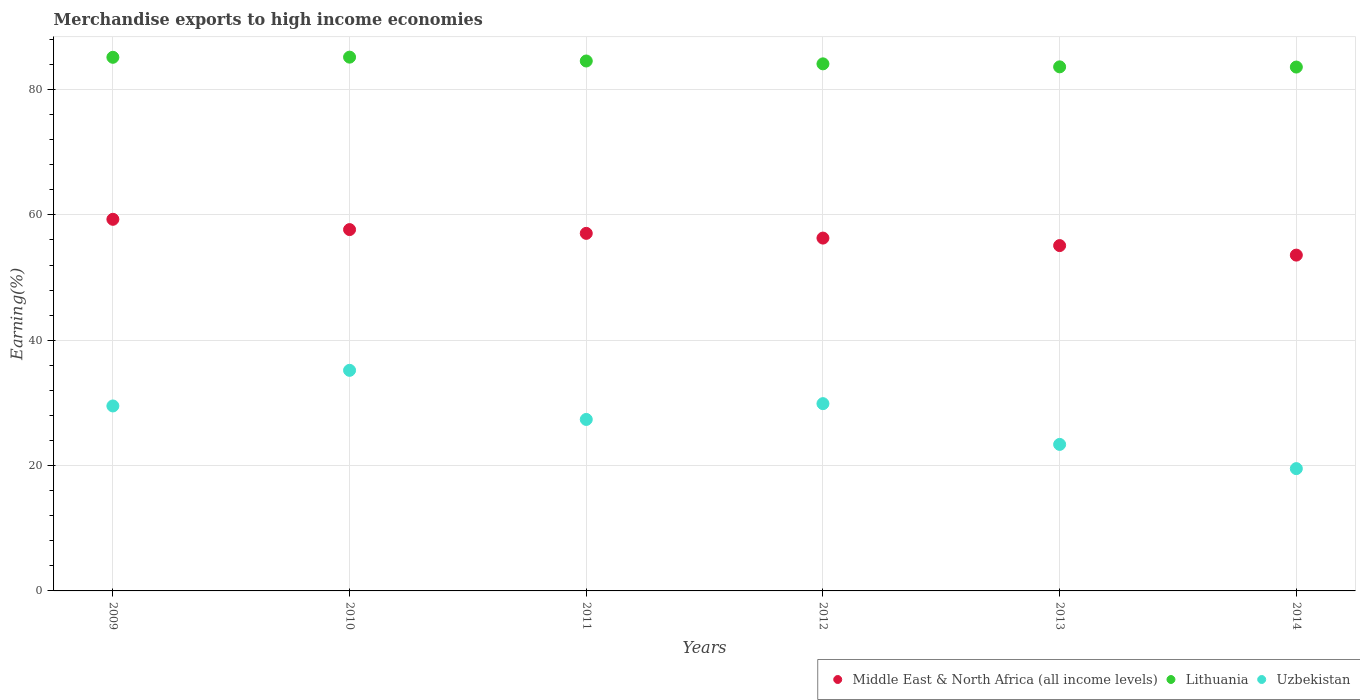What is the percentage of amount earned from merchandise exports in Middle East & North Africa (all income levels) in 2013?
Provide a short and direct response. 55.1. Across all years, what is the maximum percentage of amount earned from merchandise exports in Uzbekistan?
Your answer should be very brief. 35.2. Across all years, what is the minimum percentage of amount earned from merchandise exports in Lithuania?
Offer a terse response. 83.59. In which year was the percentage of amount earned from merchandise exports in Uzbekistan minimum?
Keep it short and to the point. 2014. What is the total percentage of amount earned from merchandise exports in Uzbekistan in the graph?
Ensure brevity in your answer.  164.84. What is the difference between the percentage of amount earned from merchandise exports in Uzbekistan in 2009 and that in 2010?
Offer a very short reply. -5.68. What is the difference between the percentage of amount earned from merchandise exports in Middle East & North Africa (all income levels) in 2014 and the percentage of amount earned from merchandise exports in Lithuania in 2009?
Ensure brevity in your answer.  -31.56. What is the average percentage of amount earned from merchandise exports in Lithuania per year?
Provide a succinct answer. 84.36. In the year 2014, what is the difference between the percentage of amount earned from merchandise exports in Lithuania and percentage of amount earned from merchandise exports in Uzbekistan?
Provide a succinct answer. 64.07. What is the ratio of the percentage of amount earned from merchandise exports in Lithuania in 2011 to that in 2013?
Your response must be concise. 1.01. Is the percentage of amount earned from merchandise exports in Middle East & North Africa (all income levels) in 2012 less than that in 2013?
Provide a succinct answer. No. What is the difference between the highest and the second highest percentage of amount earned from merchandise exports in Middle East & North Africa (all income levels)?
Ensure brevity in your answer.  1.64. What is the difference between the highest and the lowest percentage of amount earned from merchandise exports in Uzbekistan?
Your answer should be very brief. 15.68. In how many years, is the percentage of amount earned from merchandise exports in Uzbekistan greater than the average percentage of amount earned from merchandise exports in Uzbekistan taken over all years?
Provide a short and direct response. 3. Is it the case that in every year, the sum of the percentage of amount earned from merchandise exports in Middle East & North Africa (all income levels) and percentage of amount earned from merchandise exports in Lithuania  is greater than the percentage of amount earned from merchandise exports in Uzbekistan?
Keep it short and to the point. Yes. Does the percentage of amount earned from merchandise exports in Lithuania monotonically increase over the years?
Your answer should be compact. No. How many dotlines are there?
Provide a short and direct response. 3. What is the difference between two consecutive major ticks on the Y-axis?
Your answer should be compact. 20. Are the values on the major ticks of Y-axis written in scientific E-notation?
Keep it short and to the point. No. Does the graph contain any zero values?
Keep it short and to the point. No. Does the graph contain grids?
Make the answer very short. Yes. Where does the legend appear in the graph?
Offer a very short reply. Bottom right. How many legend labels are there?
Provide a succinct answer. 3. How are the legend labels stacked?
Provide a short and direct response. Horizontal. What is the title of the graph?
Keep it short and to the point. Merchandise exports to high income economies. What is the label or title of the X-axis?
Your response must be concise. Years. What is the label or title of the Y-axis?
Give a very brief answer. Earning(%). What is the Earning(%) of Middle East & North Africa (all income levels) in 2009?
Your answer should be compact. 59.29. What is the Earning(%) in Lithuania in 2009?
Provide a succinct answer. 85.14. What is the Earning(%) in Uzbekistan in 2009?
Provide a short and direct response. 29.51. What is the Earning(%) of Middle East & North Africa (all income levels) in 2010?
Your response must be concise. 57.65. What is the Earning(%) in Lithuania in 2010?
Keep it short and to the point. 85.17. What is the Earning(%) of Uzbekistan in 2010?
Give a very brief answer. 35.2. What is the Earning(%) in Middle East & North Africa (all income levels) in 2011?
Your response must be concise. 57.05. What is the Earning(%) of Lithuania in 2011?
Your answer should be very brief. 84.55. What is the Earning(%) in Uzbekistan in 2011?
Your response must be concise. 27.36. What is the Earning(%) of Middle East & North Africa (all income levels) in 2012?
Keep it short and to the point. 56.3. What is the Earning(%) of Lithuania in 2012?
Ensure brevity in your answer.  84.1. What is the Earning(%) in Uzbekistan in 2012?
Offer a very short reply. 29.88. What is the Earning(%) in Middle East & North Africa (all income levels) in 2013?
Ensure brevity in your answer.  55.1. What is the Earning(%) in Lithuania in 2013?
Your response must be concise. 83.62. What is the Earning(%) in Uzbekistan in 2013?
Ensure brevity in your answer.  23.38. What is the Earning(%) of Middle East & North Africa (all income levels) in 2014?
Give a very brief answer. 53.58. What is the Earning(%) in Lithuania in 2014?
Keep it short and to the point. 83.59. What is the Earning(%) of Uzbekistan in 2014?
Give a very brief answer. 19.51. Across all years, what is the maximum Earning(%) of Middle East & North Africa (all income levels)?
Offer a terse response. 59.29. Across all years, what is the maximum Earning(%) of Lithuania?
Ensure brevity in your answer.  85.17. Across all years, what is the maximum Earning(%) in Uzbekistan?
Make the answer very short. 35.2. Across all years, what is the minimum Earning(%) of Middle East & North Africa (all income levels)?
Offer a terse response. 53.58. Across all years, what is the minimum Earning(%) in Lithuania?
Your answer should be very brief. 83.59. Across all years, what is the minimum Earning(%) in Uzbekistan?
Your answer should be very brief. 19.51. What is the total Earning(%) in Middle East & North Africa (all income levels) in the graph?
Your response must be concise. 338.98. What is the total Earning(%) of Lithuania in the graph?
Your answer should be compact. 506.17. What is the total Earning(%) of Uzbekistan in the graph?
Your answer should be very brief. 164.84. What is the difference between the Earning(%) in Middle East & North Africa (all income levels) in 2009 and that in 2010?
Give a very brief answer. 1.64. What is the difference between the Earning(%) of Lithuania in 2009 and that in 2010?
Offer a terse response. -0.02. What is the difference between the Earning(%) of Uzbekistan in 2009 and that in 2010?
Your answer should be compact. -5.68. What is the difference between the Earning(%) of Middle East & North Africa (all income levels) in 2009 and that in 2011?
Your answer should be compact. 2.24. What is the difference between the Earning(%) in Lithuania in 2009 and that in 2011?
Your answer should be very brief. 0.59. What is the difference between the Earning(%) in Uzbekistan in 2009 and that in 2011?
Your answer should be very brief. 2.15. What is the difference between the Earning(%) of Middle East & North Africa (all income levels) in 2009 and that in 2012?
Ensure brevity in your answer.  3. What is the difference between the Earning(%) of Lithuania in 2009 and that in 2012?
Offer a terse response. 1.05. What is the difference between the Earning(%) of Uzbekistan in 2009 and that in 2012?
Your response must be concise. -0.37. What is the difference between the Earning(%) in Middle East & North Africa (all income levels) in 2009 and that in 2013?
Make the answer very short. 4.19. What is the difference between the Earning(%) in Lithuania in 2009 and that in 2013?
Provide a succinct answer. 1.52. What is the difference between the Earning(%) of Uzbekistan in 2009 and that in 2013?
Provide a succinct answer. 6.13. What is the difference between the Earning(%) in Middle East & North Africa (all income levels) in 2009 and that in 2014?
Make the answer very short. 5.71. What is the difference between the Earning(%) of Lithuania in 2009 and that in 2014?
Provide a succinct answer. 1.56. What is the difference between the Earning(%) in Uzbekistan in 2009 and that in 2014?
Make the answer very short. 10. What is the difference between the Earning(%) of Middle East & North Africa (all income levels) in 2010 and that in 2011?
Ensure brevity in your answer.  0.6. What is the difference between the Earning(%) in Lithuania in 2010 and that in 2011?
Your response must be concise. 0.61. What is the difference between the Earning(%) of Uzbekistan in 2010 and that in 2011?
Make the answer very short. 7.83. What is the difference between the Earning(%) in Middle East & North Africa (all income levels) in 2010 and that in 2012?
Your answer should be very brief. 1.35. What is the difference between the Earning(%) of Lithuania in 2010 and that in 2012?
Give a very brief answer. 1.07. What is the difference between the Earning(%) of Uzbekistan in 2010 and that in 2012?
Keep it short and to the point. 5.32. What is the difference between the Earning(%) in Middle East & North Africa (all income levels) in 2010 and that in 2013?
Provide a short and direct response. 2.55. What is the difference between the Earning(%) of Lithuania in 2010 and that in 2013?
Your answer should be compact. 1.55. What is the difference between the Earning(%) of Uzbekistan in 2010 and that in 2013?
Your response must be concise. 11.82. What is the difference between the Earning(%) in Middle East & North Africa (all income levels) in 2010 and that in 2014?
Your answer should be very brief. 4.07. What is the difference between the Earning(%) of Lithuania in 2010 and that in 2014?
Your answer should be very brief. 1.58. What is the difference between the Earning(%) in Uzbekistan in 2010 and that in 2014?
Your answer should be very brief. 15.68. What is the difference between the Earning(%) in Middle East & North Africa (all income levels) in 2011 and that in 2012?
Keep it short and to the point. 0.75. What is the difference between the Earning(%) in Lithuania in 2011 and that in 2012?
Your answer should be very brief. 0.46. What is the difference between the Earning(%) of Uzbekistan in 2011 and that in 2012?
Provide a succinct answer. -2.52. What is the difference between the Earning(%) in Middle East & North Africa (all income levels) in 2011 and that in 2013?
Your answer should be compact. 1.95. What is the difference between the Earning(%) of Lithuania in 2011 and that in 2013?
Your answer should be compact. 0.93. What is the difference between the Earning(%) of Uzbekistan in 2011 and that in 2013?
Your response must be concise. 3.98. What is the difference between the Earning(%) of Middle East & North Africa (all income levels) in 2011 and that in 2014?
Provide a short and direct response. 3.47. What is the difference between the Earning(%) in Lithuania in 2011 and that in 2014?
Offer a terse response. 0.97. What is the difference between the Earning(%) of Uzbekistan in 2011 and that in 2014?
Your answer should be compact. 7.85. What is the difference between the Earning(%) of Middle East & North Africa (all income levels) in 2012 and that in 2013?
Offer a very short reply. 1.2. What is the difference between the Earning(%) of Lithuania in 2012 and that in 2013?
Provide a short and direct response. 0.48. What is the difference between the Earning(%) in Uzbekistan in 2012 and that in 2013?
Your answer should be compact. 6.5. What is the difference between the Earning(%) of Middle East & North Africa (all income levels) in 2012 and that in 2014?
Your answer should be very brief. 2.72. What is the difference between the Earning(%) in Lithuania in 2012 and that in 2014?
Your answer should be compact. 0.51. What is the difference between the Earning(%) in Uzbekistan in 2012 and that in 2014?
Your response must be concise. 10.37. What is the difference between the Earning(%) of Middle East & North Africa (all income levels) in 2013 and that in 2014?
Offer a very short reply. 1.52. What is the difference between the Earning(%) in Lithuania in 2013 and that in 2014?
Ensure brevity in your answer.  0.03. What is the difference between the Earning(%) of Uzbekistan in 2013 and that in 2014?
Your answer should be very brief. 3.86. What is the difference between the Earning(%) in Middle East & North Africa (all income levels) in 2009 and the Earning(%) in Lithuania in 2010?
Provide a short and direct response. -25.87. What is the difference between the Earning(%) in Middle East & North Africa (all income levels) in 2009 and the Earning(%) in Uzbekistan in 2010?
Offer a terse response. 24.1. What is the difference between the Earning(%) in Lithuania in 2009 and the Earning(%) in Uzbekistan in 2010?
Offer a terse response. 49.95. What is the difference between the Earning(%) of Middle East & North Africa (all income levels) in 2009 and the Earning(%) of Lithuania in 2011?
Provide a succinct answer. -25.26. What is the difference between the Earning(%) of Middle East & North Africa (all income levels) in 2009 and the Earning(%) of Uzbekistan in 2011?
Your answer should be compact. 31.93. What is the difference between the Earning(%) in Lithuania in 2009 and the Earning(%) in Uzbekistan in 2011?
Your response must be concise. 57.78. What is the difference between the Earning(%) of Middle East & North Africa (all income levels) in 2009 and the Earning(%) of Lithuania in 2012?
Offer a very short reply. -24.8. What is the difference between the Earning(%) of Middle East & North Africa (all income levels) in 2009 and the Earning(%) of Uzbekistan in 2012?
Offer a very short reply. 29.41. What is the difference between the Earning(%) in Lithuania in 2009 and the Earning(%) in Uzbekistan in 2012?
Provide a succinct answer. 55.26. What is the difference between the Earning(%) of Middle East & North Africa (all income levels) in 2009 and the Earning(%) of Lithuania in 2013?
Provide a short and direct response. -24.33. What is the difference between the Earning(%) in Middle East & North Africa (all income levels) in 2009 and the Earning(%) in Uzbekistan in 2013?
Your answer should be very brief. 35.92. What is the difference between the Earning(%) in Lithuania in 2009 and the Earning(%) in Uzbekistan in 2013?
Keep it short and to the point. 61.77. What is the difference between the Earning(%) of Middle East & North Africa (all income levels) in 2009 and the Earning(%) of Lithuania in 2014?
Offer a terse response. -24.29. What is the difference between the Earning(%) in Middle East & North Africa (all income levels) in 2009 and the Earning(%) in Uzbekistan in 2014?
Provide a short and direct response. 39.78. What is the difference between the Earning(%) of Lithuania in 2009 and the Earning(%) of Uzbekistan in 2014?
Make the answer very short. 65.63. What is the difference between the Earning(%) in Middle East & North Africa (all income levels) in 2010 and the Earning(%) in Lithuania in 2011?
Make the answer very short. -26.9. What is the difference between the Earning(%) in Middle East & North Africa (all income levels) in 2010 and the Earning(%) in Uzbekistan in 2011?
Provide a succinct answer. 30.29. What is the difference between the Earning(%) of Lithuania in 2010 and the Earning(%) of Uzbekistan in 2011?
Your answer should be compact. 57.8. What is the difference between the Earning(%) in Middle East & North Africa (all income levels) in 2010 and the Earning(%) in Lithuania in 2012?
Offer a very short reply. -26.45. What is the difference between the Earning(%) of Middle East & North Africa (all income levels) in 2010 and the Earning(%) of Uzbekistan in 2012?
Provide a short and direct response. 27.77. What is the difference between the Earning(%) in Lithuania in 2010 and the Earning(%) in Uzbekistan in 2012?
Provide a short and direct response. 55.29. What is the difference between the Earning(%) in Middle East & North Africa (all income levels) in 2010 and the Earning(%) in Lithuania in 2013?
Ensure brevity in your answer.  -25.97. What is the difference between the Earning(%) in Middle East & North Africa (all income levels) in 2010 and the Earning(%) in Uzbekistan in 2013?
Provide a short and direct response. 34.27. What is the difference between the Earning(%) of Lithuania in 2010 and the Earning(%) of Uzbekistan in 2013?
Your answer should be compact. 61.79. What is the difference between the Earning(%) of Middle East & North Africa (all income levels) in 2010 and the Earning(%) of Lithuania in 2014?
Offer a terse response. -25.93. What is the difference between the Earning(%) of Middle East & North Africa (all income levels) in 2010 and the Earning(%) of Uzbekistan in 2014?
Your answer should be compact. 38.14. What is the difference between the Earning(%) of Lithuania in 2010 and the Earning(%) of Uzbekistan in 2014?
Keep it short and to the point. 65.65. What is the difference between the Earning(%) in Middle East & North Africa (all income levels) in 2011 and the Earning(%) in Lithuania in 2012?
Your answer should be very brief. -27.05. What is the difference between the Earning(%) in Middle East & North Africa (all income levels) in 2011 and the Earning(%) in Uzbekistan in 2012?
Make the answer very short. 27.17. What is the difference between the Earning(%) in Lithuania in 2011 and the Earning(%) in Uzbekistan in 2012?
Make the answer very short. 54.67. What is the difference between the Earning(%) of Middle East & North Africa (all income levels) in 2011 and the Earning(%) of Lithuania in 2013?
Your answer should be compact. -26.57. What is the difference between the Earning(%) in Middle East & North Africa (all income levels) in 2011 and the Earning(%) in Uzbekistan in 2013?
Ensure brevity in your answer.  33.67. What is the difference between the Earning(%) in Lithuania in 2011 and the Earning(%) in Uzbekistan in 2013?
Your answer should be very brief. 61.18. What is the difference between the Earning(%) in Middle East & North Africa (all income levels) in 2011 and the Earning(%) in Lithuania in 2014?
Your answer should be very brief. -26.54. What is the difference between the Earning(%) of Middle East & North Africa (all income levels) in 2011 and the Earning(%) of Uzbekistan in 2014?
Offer a terse response. 37.54. What is the difference between the Earning(%) in Lithuania in 2011 and the Earning(%) in Uzbekistan in 2014?
Your answer should be compact. 65.04. What is the difference between the Earning(%) of Middle East & North Africa (all income levels) in 2012 and the Earning(%) of Lithuania in 2013?
Provide a succinct answer. -27.32. What is the difference between the Earning(%) in Middle East & North Africa (all income levels) in 2012 and the Earning(%) in Uzbekistan in 2013?
Give a very brief answer. 32.92. What is the difference between the Earning(%) of Lithuania in 2012 and the Earning(%) of Uzbekistan in 2013?
Your answer should be very brief. 60.72. What is the difference between the Earning(%) in Middle East & North Africa (all income levels) in 2012 and the Earning(%) in Lithuania in 2014?
Your response must be concise. -27.29. What is the difference between the Earning(%) of Middle East & North Africa (all income levels) in 2012 and the Earning(%) of Uzbekistan in 2014?
Provide a short and direct response. 36.78. What is the difference between the Earning(%) of Lithuania in 2012 and the Earning(%) of Uzbekistan in 2014?
Make the answer very short. 64.58. What is the difference between the Earning(%) of Middle East & North Africa (all income levels) in 2013 and the Earning(%) of Lithuania in 2014?
Give a very brief answer. -28.49. What is the difference between the Earning(%) of Middle East & North Africa (all income levels) in 2013 and the Earning(%) of Uzbekistan in 2014?
Offer a very short reply. 35.59. What is the difference between the Earning(%) of Lithuania in 2013 and the Earning(%) of Uzbekistan in 2014?
Offer a terse response. 64.11. What is the average Earning(%) of Middle East & North Africa (all income levels) per year?
Your response must be concise. 56.5. What is the average Earning(%) in Lithuania per year?
Your answer should be very brief. 84.36. What is the average Earning(%) of Uzbekistan per year?
Offer a very short reply. 27.47. In the year 2009, what is the difference between the Earning(%) of Middle East & North Africa (all income levels) and Earning(%) of Lithuania?
Your response must be concise. -25.85. In the year 2009, what is the difference between the Earning(%) of Middle East & North Africa (all income levels) and Earning(%) of Uzbekistan?
Offer a very short reply. 29.78. In the year 2009, what is the difference between the Earning(%) of Lithuania and Earning(%) of Uzbekistan?
Provide a short and direct response. 55.63. In the year 2010, what is the difference between the Earning(%) of Middle East & North Africa (all income levels) and Earning(%) of Lithuania?
Offer a very short reply. -27.51. In the year 2010, what is the difference between the Earning(%) in Middle East & North Africa (all income levels) and Earning(%) in Uzbekistan?
Make the answer very short. 22.46. In the year 2010, what is the difference between the Earning(%) in Lithuania and Earning(%) in Uzbekistan?
Your answer should be very brief. 49.97. In the year 2011, what is the difference between the Earning(%) in Middle East & North Africa (all income levels) and Earning(%) in Lithuania?
Make the answer very short. -27.5. In the year 2011, what is the difference between the Earning(%) of Middle East & North Africa (all income levels) and Earning(%) of Uzbekistan?
Provide a short and direct response. 29.69. In the year 2011, what is the difference between the Earning(%) in Lithuania and Earning(%) in Uzbekistan?
Keep it short and to the point. 57.19. In the year 2012, what is the difference between the Earning(%) of Middle East & North Africa (all income levels) and Earning(%) of Lithuania?
Keep it short and to the point. -27.8. In the year 2012, what is the difference between the Earning(%) in Middle East & North Africa (all income levels) and Earning(%) in Uzbekistan?
Offer a very short reply. 26.42. In the year 2012, what is the difference between the Earning(%) in Lithuania and Earning(%) in Uzbekistan?
Provide a short and direct response. 54.22. In the year 2013, what is the difference between the Earning(%) of Middle East & North Africa (all income levels) and Earning(%) of Lithuania?
Offer a very short reply. -28.52. In the year 2013, what is the difference between the Earning(%) in Middle East & North Africa (all income levels) and Earning(%) in Uzbekistan?
Give a very brief answer. 31.72. In the year 2013, what is the difference between the Earning(%) in Lithuania and Earning(%) in Uzbekistan?
Give a very brief answer. 60.24. In the year 2014, what is the difference between the Earning(%) in Middle East & North Africa (all income levels) and Earning(%) in Lithuania?
Provide a succinct answer. -30.01. In the year 2014, what is the difference between the Earning(%) of Middle East & North Africa (all income levels) and Earning(%) of Uzbekistan?
Provide a succinct answer. 34.07. In the year 2014, what is the difference between the Earning(%) of Lithuania and Earning(%) of Uzbekistan?
Your answer should be very brief. 64.07. What is the ratio of the Earning(%) of Middle East & North Africa (all income levels) in 2009 to that in 2010?
Ensure brevity in your answer.  1.03. What is the ratio of the Earning(%) in Uzbekistan in 2009 to that in 2010?
Give a very brief answer. 0.84. What is the ratio of the Earning(%) of Middle East & North Africa (all income levels) in 2009 to that in 2011?
Provide a short and direct response. 1.04. What is the ratio of the Earning(%) in Lithuania in 2009 to that in 2011?
Your answer should be very brief. 1.01. What is the ratio of the Earning(%) of Uzbekistan in 2009 to that in 2011?
Provide a succinct answer. 1.08. What is the ratio of the Earning(%) in Middle East & North Africa (all income levels) in 2009 to that in 2012?
Keep it short and to the point. 1.05. What is the ratio of the Earning(%) in Lithuania in 2009 to that in 2012?
Keep it short and to the point. 1.01. What is the ratio of the Earning(%) of Middle East & North Africa (all income levels) in 2009 to that in 2013?
Your response must be concise. 1.08. What is the ratio of the Earning(%) of Lithuania in 2009 to that in 2013?
Offer a terse response. 1.02. What is the ratio of the Earning(%) of Uzbekistan in 2009 to that in 2013?
Ensure brevity in your answer.  1.26. What is the ratio of the Earning(%) in Middle East & North Africa (all income levels) in 2009 to that in 2014?
Keep it short and to the point. 1.11. What is the ratio of the Earning(%) in Lithuania in 2009 to that in 2014?
Keep it short and to the point. 1.02. What is the ratio of the Earning(%) in Uzbekistan in 2009 to that in 2014?
Your answer should be compact. 1.51. What is the ratio of the Earning(%) in Middle East & North Africa (all income levels) in 2010 to that in 2011?
Give a very brief answer. 1.01. What is the ratio of the Earning(%) in Lithuania in 2010 to that in 2011?
Provide a short and direct response. 1.01. What is the ratio of the Earning(%) in Uzbekistan in 2010 to that in 2011?
Provide a succinct answer. 1.29. What is the ratio of the Earning(%) in Middle East & North Africa (all income levels) in 2010 to that in 2012?
Offer a very short reply. 1.02. What is the ratio of the Earning(%) in Lithuania in 2010 to that in 2012?
Your response must be concise. 1.01. What is the ratio of the Earning(%) of Uzbekistan in 2010 to that in 2012?
Offer a very short reply. 1.18. What is the ratio of the Earning(%) of Middle East & North Africa (all income levels) in 2010 to that in 2013?
Offer a terse response. 1.05. What is the ratio of the Earning(%) of Lithuania in 2010 to that in 2013?
Your response must be concise. 1.02. What is the ratio of the Earning(%) of Uzbekistan in 2010 to that in 2013?
Provide a short and direct response. 1.51. What is the ratio of the Earning(%) in Middle East & North Africa (all income levels) in 2010 to that in 2014?
Provide a succinct answer. 1.08. What is the ratio of the Earning(%) of Lithuania in 2010 to that in 2014?
Give a very brief answer. 1.02. What is the ratio of the Earning(%) in Uzbekistan in 2010 to that in 2014?
Your answer should be compact. 1.8. What is the ratio of the Earning(%) in Middle East & North Africa (all income levels) in 2011 to that in 2012?
Ensure brevity in your answer.  1.01. What is the ratio of the Earning(%) of Lithuania in 2011 to that in 2012?
Keep it short and to the point. 1.01. What is the ratio of the Earning(%) in Uzbekistan in 2011 to that in 2012?
Keep it short and to the point. 0.92. What is the ratio of the Earning(%) in Middle East & North Africa (all income levels) in 2011 to that in 2013?
Your answer should be very brief. 1.04. What is the ratio of the Earning(%) of Lithuania in 2011 to that in 2013?
Ensure brevity in your answer.  1.01. What is the ratio of the Earning(%) in Uzbekistan in 2011 to that in 2013?
Give a very brief answer. 1.17. What is the ratio of the Earning(%) of Middle East & North Africa (all income levels) in 2011 to that in 2014?
Your response must be concise. 1.06. What is the ratio of the Earning(%) of Lithuania in 2011 to that in 2014?
Your answer should be very brief. 1.01. What is the ratio of the Earning(%) of Uzbekistan in 2011 to that in 2014?
Keep it short and to the point. 1.4. What is the ratio of the Earning(%) of Middle East & North Africa (all income levels) in 2012 to that in 2013?
Give a very brief answer. 1.02. What is the ratio of the Earning(%) in Lithuania in 2012 to that in 2013?
Give a very brief answer. 1.01. What is the ratio of the Earning(%) of Uzbekistan in 2012 to that in 2013?
Your response must be concise. 1.28. What is the ratio of the Earning(%) in Middle East & North Africa (all income levels) in 2012 to that in 2014?
Your answer should be compact. 1.05. What is the ratio of the Earning(%) in Uzbekistan in 2012 to that in 2014?
Offer a very short reply. 1.53. What is the ratio of the Earning(%) in Middle East & North Africa (all income levels) in 2013 to that in 2014?
Offer a very short reply. 1.03. What is the ratio of the Earning(%) in Uzbekistan in 2013 to that in 2014?
Keep it short and to the point. 1.2. What is the difference between the highest and the second highest Earning(%) of Middle East & North Africa (all income levels)?
Your answer should be compact. 1.64. What is the difference between the highest and the second highest Earning(%) in Lithuania?
Make the answer very short. 0.02. What is the difference between the highest and the second highest Earning(%) in Uzbekistan?
Provide a short and direct response. 5.32. What is the difference between the highest and the lowest Earning(%) in Middle East & North Africa (all income levels)?
Your answer should be compact. 5.71. What is the difference between the highest and the lowest Earning(%) of Lithuania?
Your answer should be very brief. 1.58. What is the difference between the highest and the lowest Earning(%) of Uzbekistan?
Ensure brevity in your answer.  15.68. 